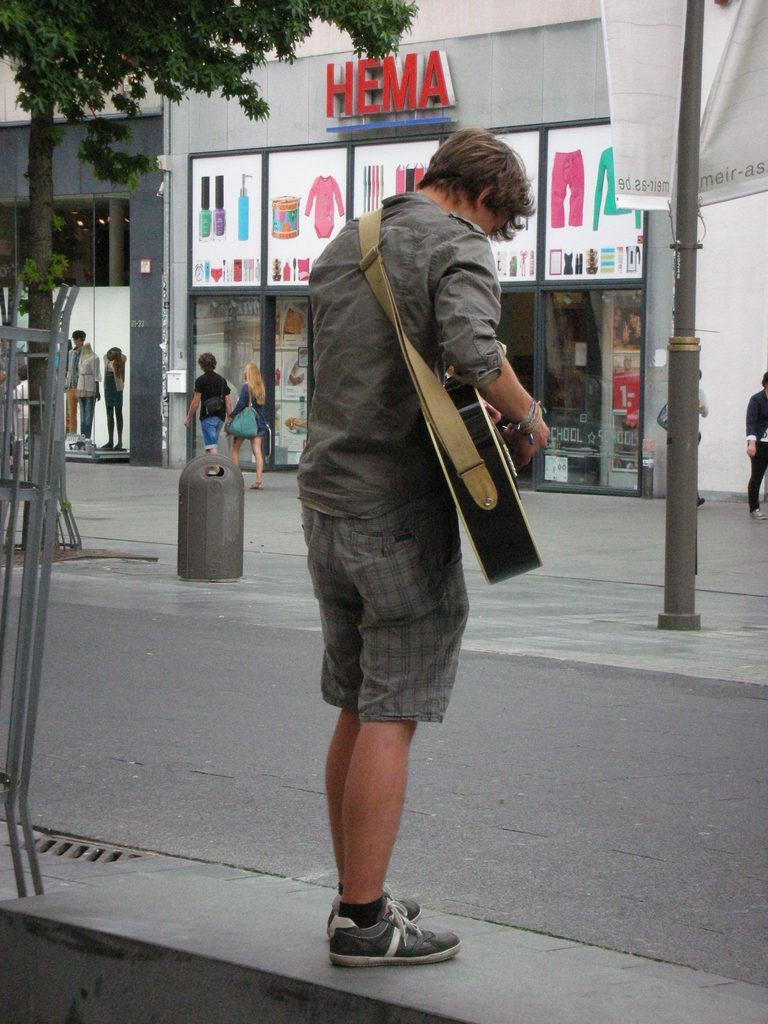How would you summarize this image in a sentence or two? This image is taken indoors. At the bottom of the image there is a road. In the middle of the image a man is standing on the road and he is playing music with a guitar. In the background there is a building with walls and doors. There are two stories with a few things. There are three mannequins. There is a text on the wall and there are a few boards with images on it. A man and a woman are walking on the road. On the left side of the image there is a railing and there is a tree. On the right side of the image there is a pole and there is a banner with a text on it. A person is standing on the road. 